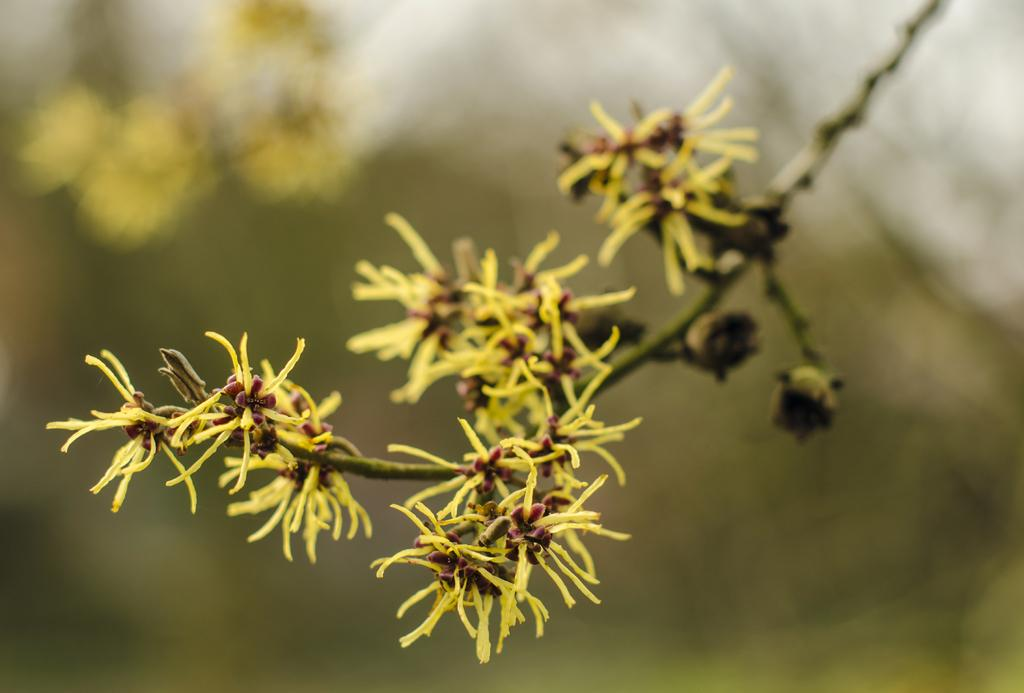What is the main subject of the image? The main subject of the image is a group of flowers. Are there any other elements in the image related to the flowers? Yes, there are buds in the image. Where are the flowers and buds located? The flowers and buds are on the branch of a tree. What type of silk is used to make the net in the image? There is no net or silk present in the image; it features a group of flowers and buds on a tree branch. 